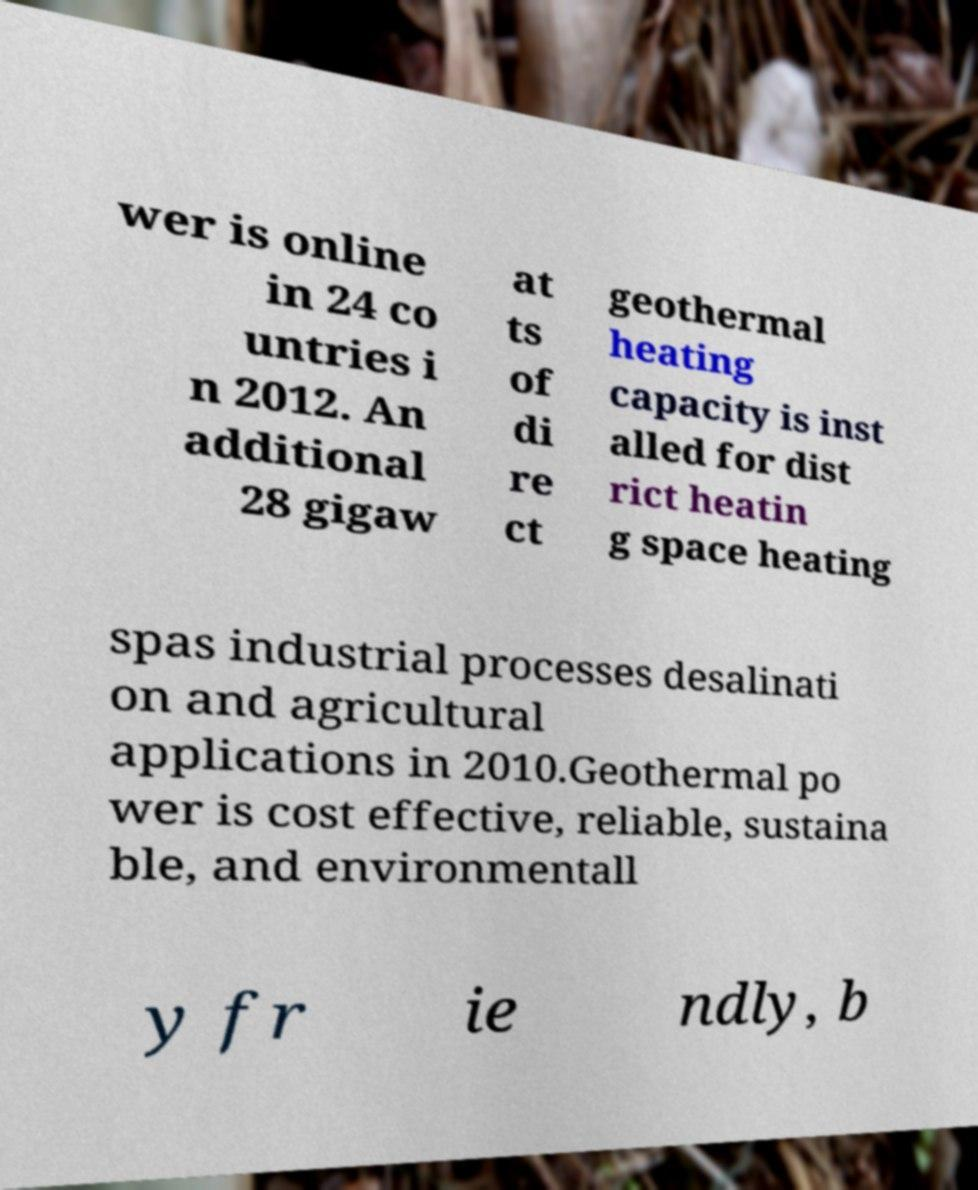What messages or text are displayed in this image? I need them in a readable, typed format. wer is online in 24 co untries i n 2012. An additional 28 gigaw at ts of di re ct geothermal heating capacity is inst alled for dist rict heatin g space heating spas industrial processes desalinati on and agricultural applications in 2010.Geothermal po wer is cost effective, reliable, sustaina ble, and environmentall y fr ie ndly, b 